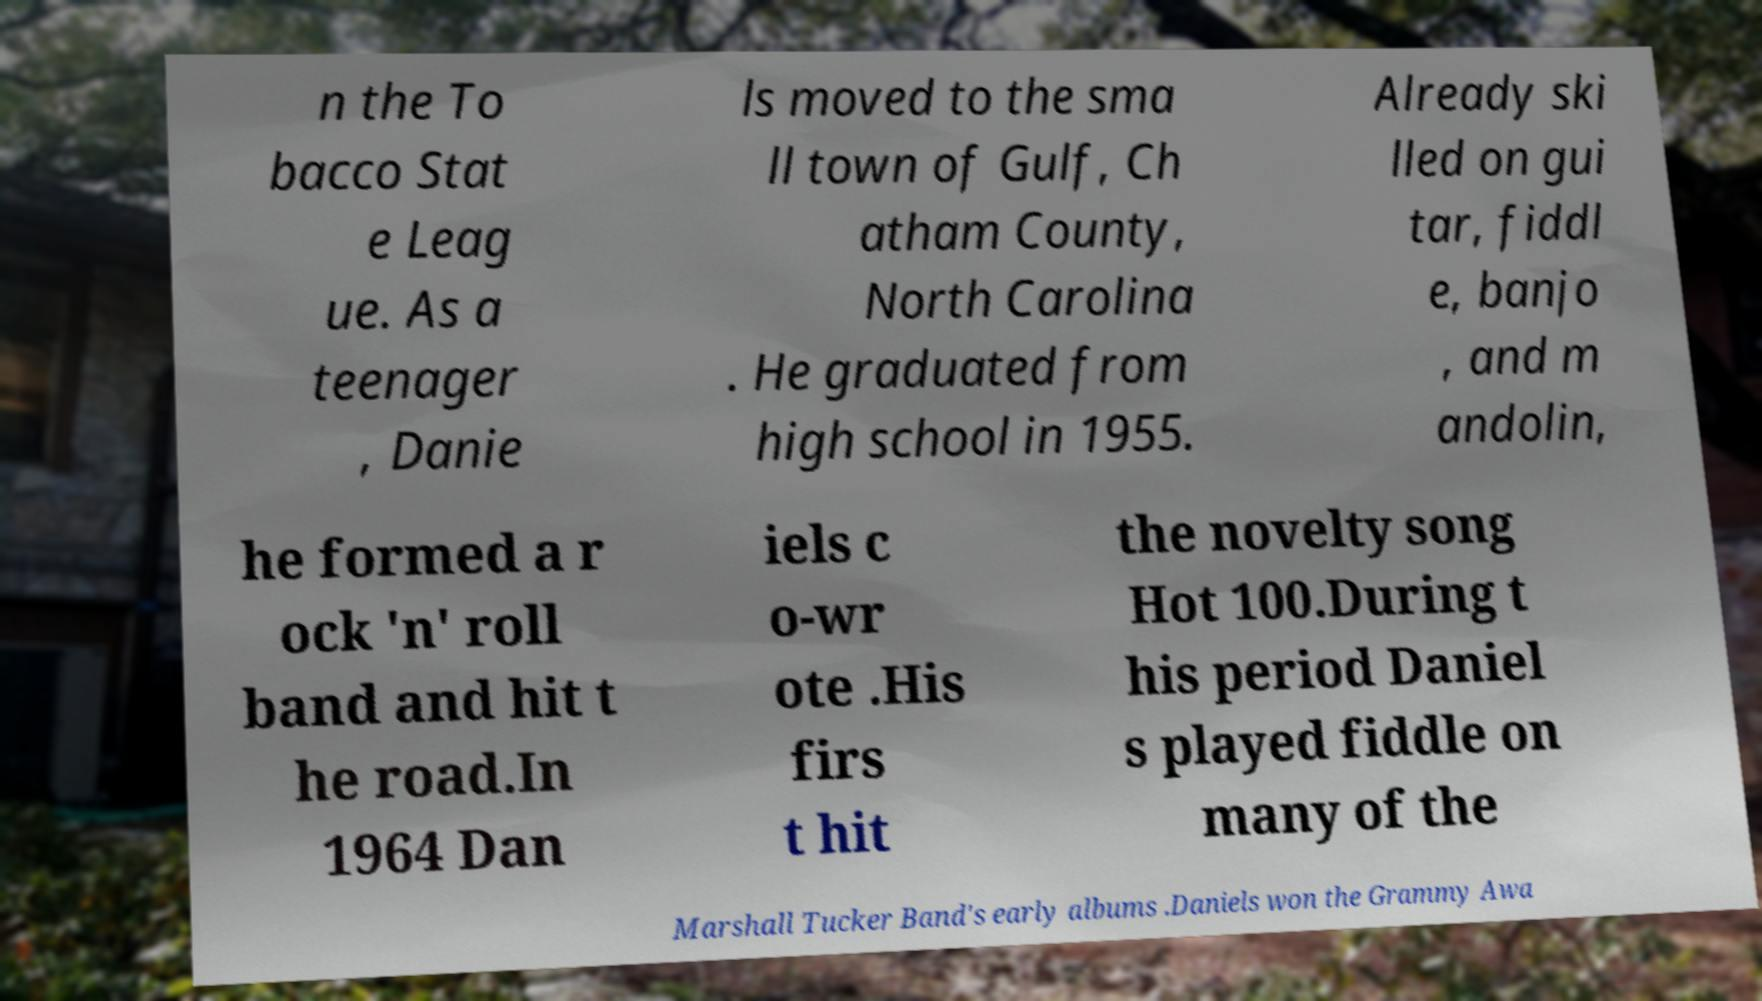For documentation purposes, I need the text within this image transcribed. Could you provide that? n the To bacco Stat e Leag ue. As a teenager , Danie ls moved to the sma ll town of Gulf, Ch atham County, North Carolina . He graduated from high school in 1955. Already ski lled on gui tar, fiddl e, banjo , and m andolin, he formed a r ock 'n' roll band and hit t he road.In 1964 Dan iels c o-wr ote .His firs t hit the novelty song Hot 100.During t his period Daniel s played fiddle on many of the Marshall Tucker Band's early albums .Daniels won the Grammy Awa 